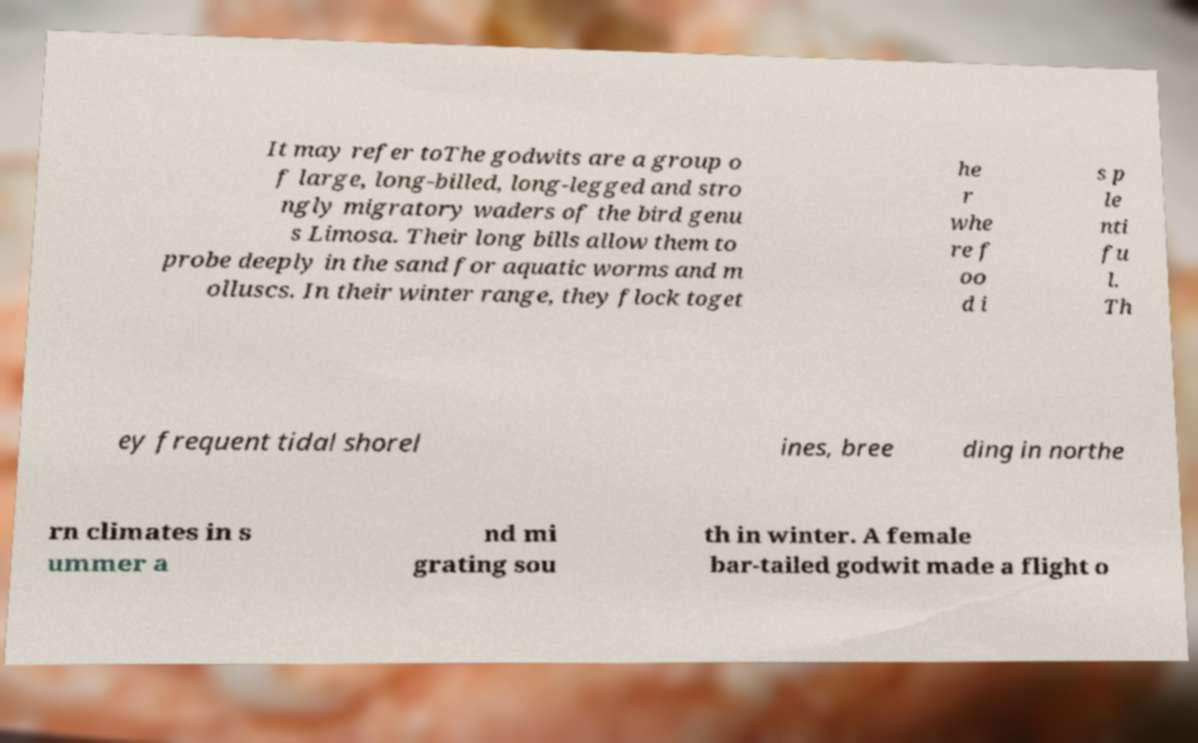Please read and relay the text visible in this image. What does it say? It may refer toThe godwits are a group o f large, long-billed, long-legged and stro ngly migratory waders of the bird genu s Limosa. Their long bills allow them to probe deeply in the sand for aquatic worms and m olluscs. In their winter range, they flock toget he r whe re f oo d i s p le nti fu l. Th ey frequent tidal shorel ines, bree ding in northe rn climates in s ummer a nd mi grating sou th in winter. A female bar-tailed godwit made a flight o 